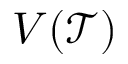<formula> <loc_0><loc_0><loc_500><loc_500>V ( \mathcal { T } )</formula> 